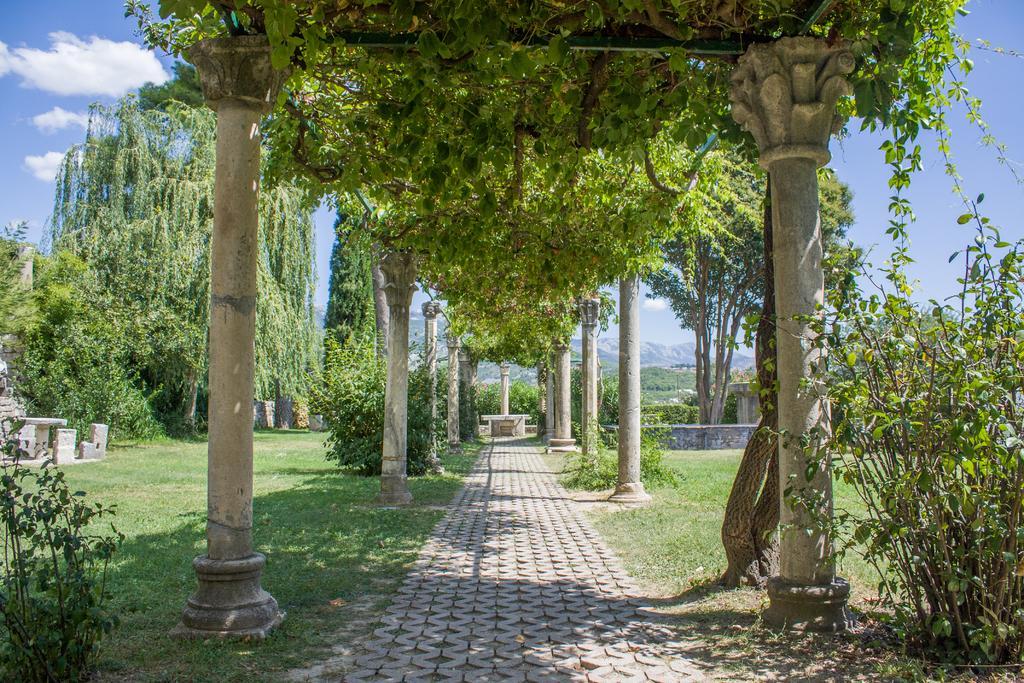How would you summarize this image in a sentence or two? In the picture we can see a park with a pillar and poles and some plants to it and besides, we can see a grass surface and plants and in the background we can see some trees and sky with clouds. 